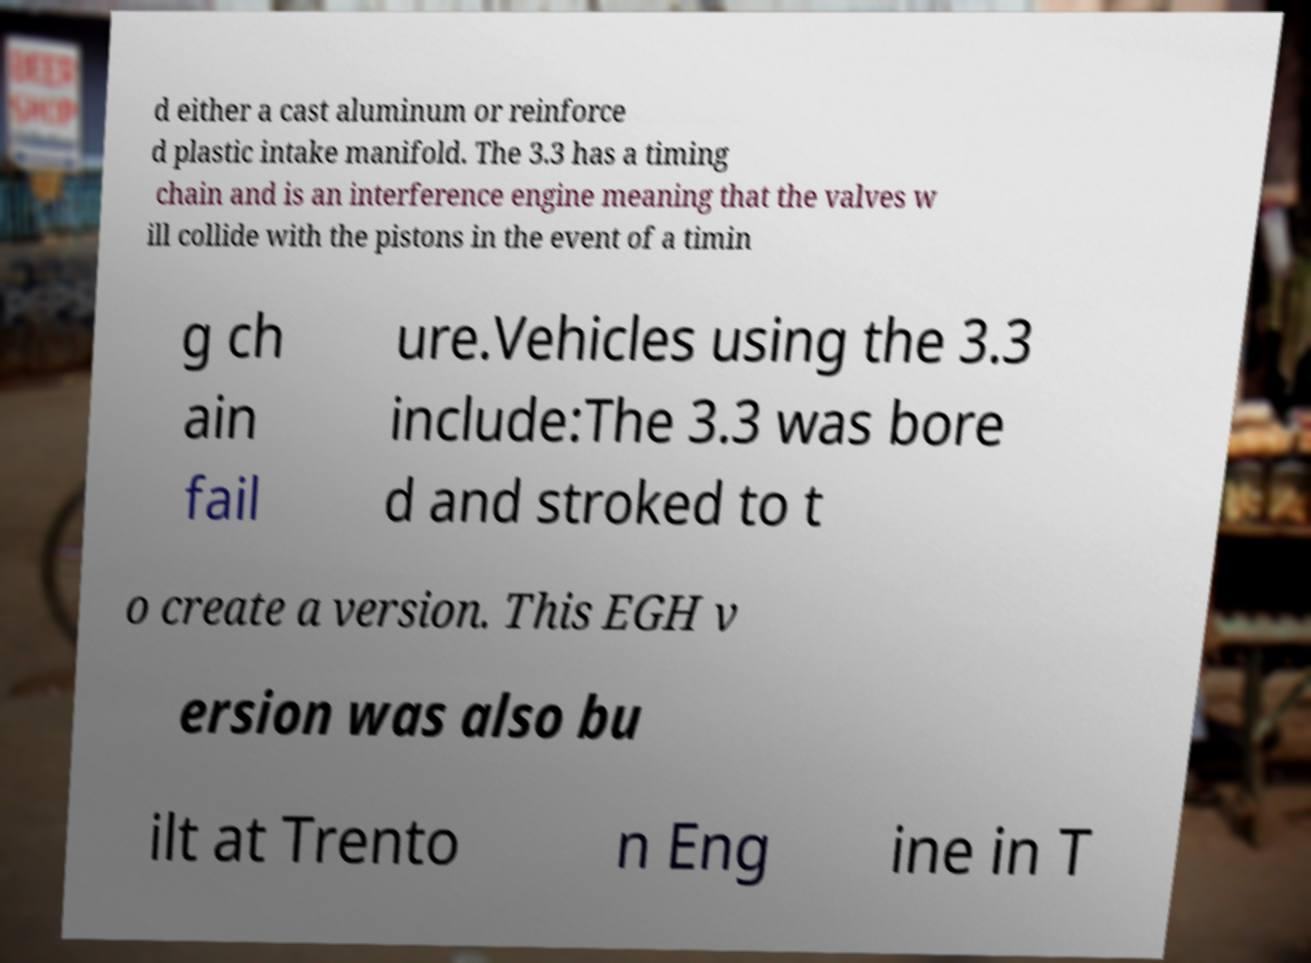Please read and relay the text visible in this image. What does it say? d either a cast aluminum or reinforce d plastic intake manifold. The 3.3 has a timing chain and is an interference engine meaning that the valves w ill collide with the pistons in the event of a timin g ch ain fail ure.Vehicles using the 3.3 include:The 3.3 was bore d and stroked to t o create a version. This EGH v ersion was also bu ilt at Trento n Eng ine in T 